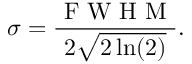Convert formula to latex. <formula><loc_0><loc_0><loc_500><loc_500>\sigma = \frac { F W H M } { 2 \sqrt { 2 \ln ( 2 ) } } .</formula> 